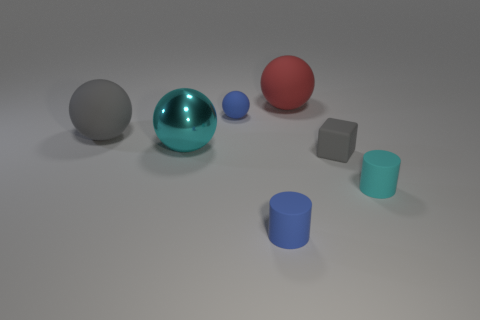There is a red matte thing; what number of red rubber things are in front of it?
Your answer should be compact. 0. Is the red thing made of the same material as the large cyan sphere?
Ensure brevity in your answer.  No. What number of objects are both behind the big gray matte sphere and to the left of the big red rubber object?
Provide a succinct answer. 1. What number of other things are there of the same color as the tiny ball?
Make the answer very short. 1. What number of cyan things are either cylinders or large matte spheres?
Provide a short and direct response. 1. The shiny thing has what size?
Your response must be concise. Large. How many matte things are either tiny things or cyan balls?
Ensure brevity in your answer.  4. Are there fewer rubber blocks than tiny rubber things?
Provide a short and direct response. Yes. What number of other objects are the same material as the big gray thing?
Offer a terse response. 5. The red object that is the same shape as the big cyan object is what size?
Offer a terse response. Large. 